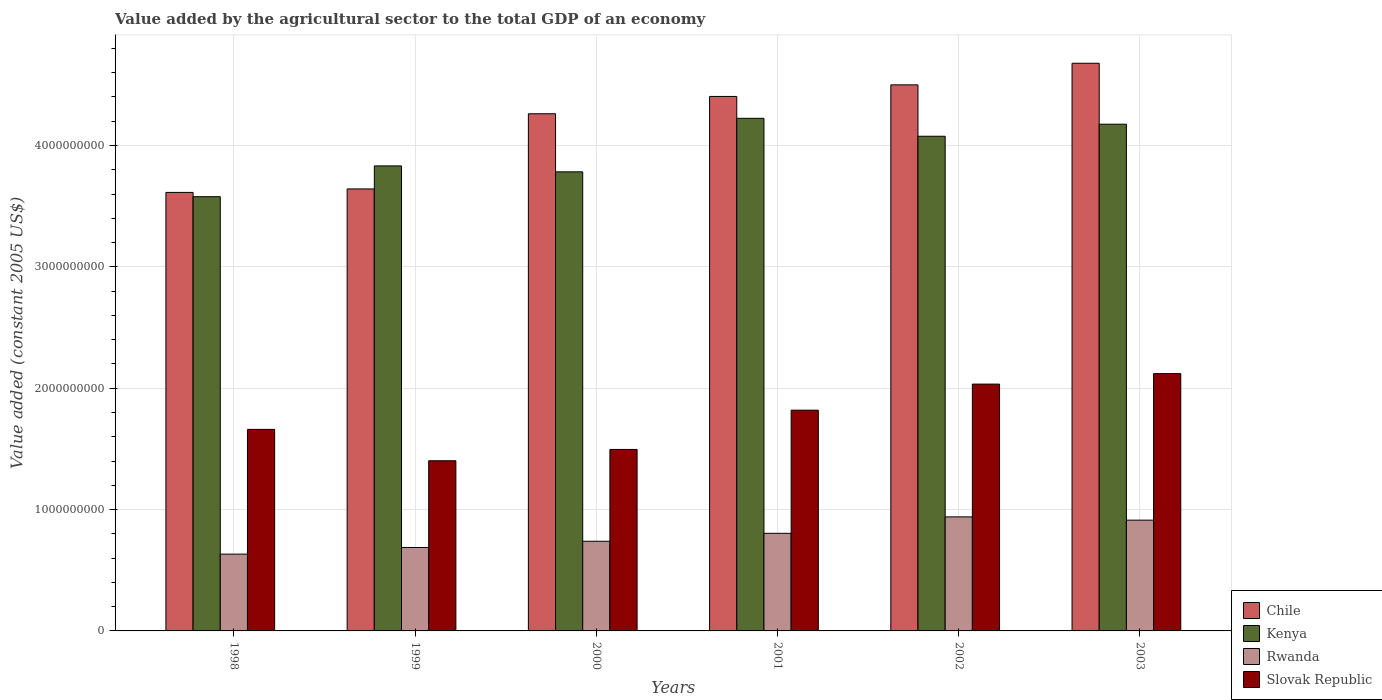How many different coloured bars are there?
Provide a short and direct response. 4. Are the number of bars per tick equal to the number of legend labels?
Give a very brief answer. Yes. How many bars are there on the 4th tick from the left?
Offer a very short reply. 4. How many bars are there on the 6th tick from the right?
Provide a short and direct response. 4. What is the label of the 5th group of bars from the left?
Keep it short and to the point. 2002. What is the value added by the agricultural sector in Kenya in 2003?
Your response must be concise. 4.17e+09. Across all years, what is the maximum value added by the agricultural sector in Kenya?
Offer a terse response. 4.22e+09. Across all years, what is the minimum value added by the agricultural sector in Rwanda?
Provide a short and direct response. 6.33e+08. In which year was the value added by the agricultural sector in Rwanda minimum?
Your answer should be very brief. 1998. What is the total value added by the agricultural sector in Rwanda in the graph?
Offer a terse response. 4.72e+09. What is the difference between the value added by the agricultural sector in Chile in 1999 and that in 2002?
Give a very brief answer. -8.57e+08. What is the difference between the value added by the agricultural sector in Rwanda in 2000 and the value added by the agricultural sector in Slovak Republic in 2001?
Keep it short and to the point. -1.08e+09. What is the average value added by the agricultural sector in Kenya per year?
Your answer should be compact. 3.94e+09. In the year 1999, what is the difference between the value added by the agricultural sector in Kenya and value added by the agricultural sector in Slovak Republic?
Your answer should be very brief. 2.43e+09. What is the ratio of the value added by the agricultural sector in Slovak Republic in 1998 to that in 2000?
Provide a succinct answer. 1.11. Is the difference between the value added by the agricultural sector in Kenya in 1999 and 2001 greater than the difference between the value added by the agricultural sector in Slovak Republic in 1999 and 2001?
Your answer should be compact. Yes. What is the difference between the highest and the second highest value added by the agricultural sector in Rwanda?
Your answer should be compact. 2.68e+07. What is the difference between the highest and the lowest value added by the agricultural sector in Kenya?
Ensure brevity in your answer.  6.46e+08. In how many years, is the value added by the agricultural sector in Slovak Republic greater than the average value added by the agricultural sector in Slovak Republic taken over all years?
Provide a succinct answer. 3. Is it the case that in every year, the sum of the value added by the agricultural sector in Rwanda and value added by the agricultural sector in Kenya is greater than the sum of value added by the agricultural sector in Chile and value added by the agricultural sector in Slovak Republic?
Make the answer very short. Yes. What does the 4th bar from the left in 2002 represents?
Your answer should be compact. Slovak Republic. Is it the case that in every year, the sum of the value added by the agricultural sector in Rwanda and value added by the agricultural sector in Slovak Republic is greater than the value added by the agricultural sector in Kenya?
Make the answer very short. No. How many bars are there?
Keep it short and to the point. 24. Are the values on the major ticks of Y-axis written in scientific E-notation?
Provide a short and direct response. No. Does the graph contain any zero values?
Your answer should be compact. No. How many legend labels are there?
Provide a short and direct response. 4. How are the legend labels stacked?
Ensure brevity in your answer.  Vertical. What is the title of the graph?
Provide a short and direct response. Value added by the agricultural sector to the total GDP of an economy. Does "Gabon" appear as one of the legend labels in the graph?
Make the answer very short. No. What is the label or title of the X-axis?
Make the answer very short. Years. What is the label or title of the Y-axis?
Offer a very short reply. Value added (constant 2005 US$). What is the Value added (constant 2005 US$) in Chile in 1998?
Provide a succinct answer. 3.61e+09. What is the Value added (constant 2005 US$) of Kenya in 1998?
Your answer should be very brief. 3.58e+09. What is the Value added (constant 2005 US$) in Rwanda in 1998?
Make the answer very short. 6.33e+08. What is the Value added (constant 2005 US$) in Slovak Republic in 1998?
Provide a succinct answer. 1.66e+09. What is the Value added (constant 2005 US$) of Chile in 1999?
Offer a very short reply. 3.64e+09. What is the Value added (constant 2005 US$) in Kenya in 1999?
Ensure brevity in your answer.  3.83e+09. What is the Value added (constant 2005 US$) in Rwanda in 1999?
Offer a very short reply. 6.87e+08. What is the Value added (constant 2005 US$) of Slovak Republic in 1999?
Provide a short and direct response. 1.40e+09. What is the Value added (constant 2005 US$) in Chile in 2000?
Give a very brief answer. 4.26e+09. What is the Value added (constant 2005 US$) in Kenya in 2000?
Your answer should be very brief. 3.78e+09. What is the Value added (constant 2005 US$) of Rwanda in 2000?
Make the answer very short. 7.39e+08. What is the Value added (constant 2005 US$) of Slovak Republic in 2000?
Offer a very short reply. 1.50e+09. What is the Value added (constant 2005 US$) of Chile in 2001?
Your response must be concise. 4.40e+09. What is the Value added (constant 2005 US$) of Kenya in 2001?
Ensure brevity in your answer.  4.22e+09. What is the Value added (constant 2005 US$) in Rwanda in 2001?
Offer a very short reply. 8.04e+08. What is the Value added (constant 2005 US$) in Slovak Republic in 2001?
Provide a short and direct response. 1.82e+09. What is the Value added (constant 2005 US$) in Chile in 2002?
Offer a very short reply. 4.50e+09. What is the Value added (constant 2005 US$) in Kenya in 2002?
Keep it short and to the point. 4.08e+09. What is the Value added (constant 2005 US$) of Rwanda in 2002?
Provide a short and direct response. 9.40e+08. What is the Value added (constant 2005 US$) of Slovak Republic in 2002?
Provide a succinct answer. 2.03e+09. What is the Value added (constant 2005 US$) of Chile in 2003?
Your answer should be very brief. 4.68e+09. What is the Value added (constant 2005 US$) of Kenya in 2003?
Provide a succinct answer. 4.17e+09. What is the Value added (constant 2005 US$) of Rwanda in 2003?
Your answer should be very brief. 9.13e+08. What is the Value added (constant 2005 US$) in Slovak Republic in 2003?
Make the answer very short. 2.12e+09. Across all years, what is the maximum Value added (constant 2005 US$) of Chile?
Give a very brief answer. 4.68e+09. Across all years, what is the maximum Value added (constant 2005 US$) of Kenya?
Provide a short and direct response. 4.22e+09. Across all years, what is the maximum Value added (constant 2005 US$) of Rwanda?
Ensure brevity in your answer.  9.40e+08. Across all years, what is the maximum Value added (constant 2005 US$) of Slovak Republic?
Offer a very short reply. 2.12e+09. Across all years, what is the minimum Value added (constant 2005 US$) in Chile?
Offer a very short reply. 3.61e+09. Across all years, what is the minimum Value added (constant 2005 US$) of Kenya?
Your response must be concise. 3.58e+09. Across all years, what is the minimum Value added (constant 2005 US$) in Rwanda?
Your answer should be very brief. 6.33e+08. Across all years, what is the minimum Value added (constant 2005 US$) of Slovak Republic?
Your answer should be very brief. 1.40e+09. What is the total Value added (constant 2005 US$) of Chile in the graph?
Your answer should be compact. 2.51e+1. What is the total Value added (constant 2005 US$) of Kenya in the graph?
Ensure brevity in your answer.  2.37e+1. What is the total Value added (constant 2005 US$) in Rwanda in the graph?
Provide a succinct answer. 4.72e+09. What is the total Value added (constant 2005 US$) in Slovak Republic in the graph?
Give a very brief answer. 1.05e+1. What is the difference between the Value added (constant 2005 US$) of Chile in 1998 and that in 1999?
Provide a succinct answer. -2.87e+07. What is the difference between the Value added (constant 2005 US$) in Kenya in 1998 and that in 1999?
Offer a very short reply. -2.54e+08. What is the difference between the Value added (constant 2005 US$) of Rwanda in 1998 and that in 1999?
Your answer should be very brief. -5.47e+07. What is the difference between the Value added (constant 2005 US$) in Slovak Republic in 1998 and that in 1999?
Your response must be concise. 2.58e+08. What is the difference between the Value added (constant 2005 US$) in Chile in 1998 and that in 2000?
Keep it short and to the point. -6.48e+08. What is the difference between the Value added (constant 2005 US$) of Kenya in 1998 and that in 2000?
Your answer should be compact. -2.05e+08. What is the difference between the Value added (constant 2005 US$) in Rwanda in 1998 and that in 2000?
Make the answer very short. -1.06e+08. What is the difference between the Value added (constant 2005 US$) in Slovak Republic in 1998 and that in 2000?
Keep it short and to the point. 1.65e+08. What is the difference between the Value added (constant 2005 US$) in Chile in 1998 and that in 2001?
Give a very brief answer. -7.91e+08. What is the difference between the Value added (constant 2005 US$) in Kenya in 1998 and that in 2001?
Your response must be concise. -6.46e+08. What is the difference between the Value added (constant 2005 US$) of Rwanda in 1998 and that in 2001?
Ensure brevity in your answer.  -1.71e+08. What is the difference between the Value added (constant 2005 US$) of Slovak Republic in 1998 and that in 2001?
Ensure brevity in your answer.  -1.58e+08. What is the difference between the Value added (constant 2005 US$) of Chile in 1998 and that in 2002?
Ensure brevity in your answer.  -8.86e+08. What is the difference between the Value added (constant 2005 US$) in Kenya in 1998 and that in 2002?
Offer a terse response. -4.98e+08. What is the difference between the Value added (constant 2005 US$) of Rwanda in 1998 and that in 2002?
Provide a short and direct response. -3.07e+08. What is the difference between the Value added (constant 2005 US$) of Slovak Republic in 1998 and that in 2002?
Provide a short and direct response. -3.73e+08. What is the difference between the Value added (constant 2005 US$) in Chile in 1998 and that in 2003?
Your answer should be compact. -1.06e+09. What is the difference between the Value added (constant 2005 US$) in Kenya in 1998 and that in 2003?
Ensure brevity in your answer.  -5.97e+08. What is the difference between the Value added (constant 2005 US$) in Rwanda in 1998 and that in 2003?
Your answer should be very brief. -2.80e+08. What is the difference between the Value added (constant 2005 US$) in Slovak Republic in 1998 and that in 2003?
Offer a very short reply. -4.59e+08. What is the difference between the Value added (constant 2005 US$) of Chile in 1999 and that in 2000?
Provide a short and direct response. -6.19e+08. What is the difference between the Value added (constant 2005 US$) of Kenya in 1999 and that in 2000?
Your answer should be very brief. 4.89e+07. What is the difference between the Value added (constant 2005 US$) of Rwanda in 1999 and that in 2000?
Your answer should be compact. -5.15e+07. What is the difference between the Value added (constant 2005 US$) in Slovak Republic in 1999 and that in 2000?
Make the answer very short. -9.32e+07. What is the difference between the Value added (constant 2005 US$) of Chile in 1999 and that in 2001?
Offer a very short reply. -7.62e+08. What is the difference between the Value added (constant 2005 US$) in Kenya in 1999 and that in 2001?
Keep it short and to the point. -3.92e+08. What is the difference between the Value added (constant 2005 US$) in Rwanda in 1999 and that in 2001?
Provide a succinct answer. -1.17e+08. What is the difference between the Value added (constant 2005 US$) of Slovak Republic in 1999 and that in 2001?
Offer a terse response. -4.17e+08. What is the difference between the Value added (constant 2005 US$) of Chile in 1999 and that in 2002?
Provide a succinct answer. -8.57e+08. What is the difference between the Value added (constant 2005 US$) of Kenya in 1999 and that in 2002?
Offer a terse response. -2.44e+08. What is the difference between the Value added (constant 2005 US$) in Rwanda in 1999 and that in 2002?
Offer a terse response. -2.52e+08. What is the difference between the Value added (constant 2005 US$) in Slovak Republic in 1999 and that in 2002?
Keep it short and to the point. -6.32e+08. What is the difference between the Value added (constant 2005 US$) in Chile in 1999 and that in 2003?
Your response must be concise. -1.04e+09. What is the difference between the Value added (constant 2005 US$) of Kenya in 1999 and that in 2003?
Keep it short and to the point. -3.43e+08. What is the difference between the Value added (constant 2005 US$) of Rwanda in 1999 and that in 2003?
Your answer should be compact. -2.25e+08. What is the difference between the Value added (constant 2005 US$) of Slovak Republic in 1999 and that in 2003?
Keep it short and to the point. -7.18e+08. What is the difference between the Value added (constant 2005 US$) in Chile in 2000 and that in 2001?
Provide a short and direct response. -1.43e+08. What is the difference between the Value added (constant 2005 US$) of Kenya in 2000 and that in 2001?
Offer a terse response. -4.41e+08. What is the difference between the Value added (constant 2005 US$) of Rwanda in 2000 and that in 2001?
Offer a terse response. -6.52e+07. What is the difference between the Value added (constant 2005 US$) of Slovak Republic in 2000 and that in 2001?
Offer a very short reply. -3.24e+08. What is the difference between the Value added (constant 2005 US$) in Chile in 2000 and that in 2002?
Your answer should be very brief. -2.38e+08. What is the difference between the Value added (constant 2005 US$) of Kenya in 2000 and that in 2002?
Your answer should be very brief. -2.93e+08. What is the difference between the Value added (constant 2005 US$) of Rwanda in 2000 and that in 2002?
Your answer should be compact. -2.01e+08. What is the difference between the Value added (constant 2005 US$) of Slovak Republic in 2000 and that in 2002?
Keep it short and to the point. -5.38e+08. What is the difference between the Value added (constant 2005 US$) of Chile in 2000 and that in 2003?
Keep it short and to the point. -4.16e+08. What is the difference between the Value added (constant 2005 US$) of Kenya in 2000 and that in 2003?
Your answer should be very brief. -3.92e+08. What is the difference between the Value added (constant 2005 US$) in Rwanda in 2000 and that in 2003?
Your response must be concise. -1.74e+08. What is the difference between the Value added (constant 2005 US$) in Slovak Republic in 2000 and that in 2003?
Your answer should be compact. -6.25e+08. What is the difference between the Value added (constant 2005 US$) in Chile in 2001 and that in 2002?
Your answer should be very brief. -9.54e+07. What is the difference between the Value added (constant 2005 US$) in Kenya in 2001 and that in 2002?
Your answer should be compact. 1.48e+08. What is the difference between the Value added (constant 2005 US$) of Rwanda in 2001 and that in 2002?
Your answer should be very brief. -1.35e+08. What is the difference between the Value added (constant 2005 US$) in Slovak Republic in 2001 and that in 2002?
Offer a very short reply. -2.15e+08. What is the difference between the Value added (constant 2005 US$) of Chile in 2001 and that in 2003?
Your answer should be compact. -2.73e+08. What is the difference between the Value added (constant 2005 US$) of Kenya in 2001 and that in 2003?
Give a very brief answer. 4.86e+07. What is the difference between the Value added (constant 2005 US$) in Rwanda in 2001 and that in 2003?
Make the answer very short. -1.09e+08. What is the difference between the Value added (constant 2005 US$) in Slovak Republic in 2001 and that in 2003?
Your response must be concise. -3.01e+08. What is the difference between the Value added (constant 2005 US$) in Chile in 2002 and that in 2003?
Your answer should be very brief. -1.78e+08. What is the difference between the Value added (constant 2005 US$) in Kenya in 2002 and that in 2003?
Ensure brevity in your answer.  -9.91e+07. What is the difference between the Value added (constant 2005 US$) of Rwanda in 2002 and that in 2003?
Offer a very short reply. 2.68e+07. What is the difference between the Value added (constant 2005 US$) of Slovak Republic in 2002 and that in 2003?
Keep it short and to the point. -8.63e+07. What is the difference between the Value added (constant 2005 US$) of Chile in 1998 and the Value added (constant 2005 US$) of Kenya in 1999?
Provide a succinct answer. -2.18e+08. What is the difference between the Value added (constant 2005 US$) of Chile in 1998 and the Value added (constant 2005 US$) of Rwanda in 1999?
Make the answer very short. 2.93e+09. What is the difference between the Value added (constant 2005 US$) in Chile in 1998 and the Value added (constant 2005 US$) in Slovak Republic in 1999?
Offer a terse response. 2.21e+09. What is the difference between the Value added (constant 2005 US$) of Kenya in 1998 and the Value added (constant 2005 US$) of Rwanda in 1999?
Provide a short and direct response. 2.89e+09. What is the difference between the Value added (constant 2005 US$) in Kenya in 1998 and the Value added (constant 2005 US$) in Slovak Republic in 1999?
Ensure brevity in your answer.  2.18e+09. What is the difference between the Value added (constant 2005 US$) in Rwanda in 1998 and the Value added (constant 2005 US$) in Slovak Republic in 1999?
Offer a very short reply. -7.69e+08. What is the difference between the Value added (constant 2005 US$) in Chile in 1998 and the Value added (constant 2005 US$) in Kenya in 2000?
Offer a very short reply. -1.70e+08. What is the difference between the Value added (constant 2005 US$) in Chile in 1998 and the Value added (constant 2005 US$) in Rwanda in 2000?
Ensure brevity in your answer.  2.87e+09. What is the difference between the Value added (constant 2005 US$) of Chile in 1998 and the Value added (constant 2005 US$) of Slovak Republic in 2000?
Offer a terse response. 2.12e+09. What is the difference between the Value added (constant 2005 US$) in Kenya in 1998 and the Value added (constant 2005 US$) in Rwanda in 2000?
Your response must be concise. 2.84e+09. What is the difference between the Value added (constant 2005 US$) of Kenya in 1998 and the Value added (constant 2005 US$) of Slovak Republic in 2000?
Keep it short and to the point. 2.08e+09. What is the difference between the Value added (constant 2005 US$) of Rwanda in 1998 and the Value added (constant 2005 US$) of Slovak Republic in 2000?
Your answer should be compact. -8.63e+08. What is the difference between the Value added (constant 2005 US$) in Chile in 1998 and the Value added (constant 2005 US$) in Kenya in 2001?
Your answer should be very brief. -6.10e+08. What is the difference between the Value added (constant 2005 US$) of Chile in 1998 and the Value added (constant 2005 US$) of Rwanda in 2001?
Your response must be concise. 2.81e+09. What is the difference between the Value added (constant 2005 US$) of Chile in 1998 and the Value added (constant 2005 US$) of Slovak Republic in 2001?
Offer a terse response. 1.79e+09. What is the difference between the Value added (constant 2005 US$) in Kenya in 1998 and the Value added (constant 2005 US$) in Rwanda in 2001?
Give a very brief answer. 2.77e+09. What is the difference between the Value added (constant 2005 US$) in Kenya in 1998 and the Value added (constant 2005 US$) in Slovak Republic in 2001?
Offer a very short reply. 1.76e+09. What is the difference between the Value added (constant 2005 US$) in Rwanda in 1998 and the Value added (constant 2005 US$) in Slovak Republic in 2001?
Your response must be concise. -1.19e+09. What is the difference between the Value added (constant 2005 US$) in Chile in 1998 and the Value added (constant 2005 US$) in Kenya in 2002?
Your response must be concise. -4.63e+08. What is the difference between the Value added (constant 2005 US$) in Chile in 1998 and the Value added (constant 2005 US$) in Rwanda in 2002?
Your answer should be compact. 2.67e+09. What is the difference between the Value added (constant 2005 US$) in Chile in 1998 and the Value added (constant 2005 US$) in Slovak Republic in 2002?
Your answer should be compact. 1.58e+09. What is the difference between the Value added (constant 2005 US$) in Kenya in 1998 and the Value added (constant 2005 US$) in Rwanda in 2002?
Your answer should be very brief. 2.64e+09. What is the difference between the Value added (constant 2005 US$) of Kenya in 1998 and the Value added (constant 2005 US$) of Slovak Republic in 2002?
Make the answer very short. 1.54e+09. What is the difference between the Value added (constant 2005 US$) of Rwanda in 1998 and the Value added (constant 2005 US$) of Slovak Republic in 2002?
Keep it short and to the point. -1.40e+09. What is the difference between the Value added (constant 2005 US$) of Chile in 1998 and the Value added (constant 2005 US$) of Kenya in 2003?
Provide a succinct answer. -5.62e+08. What is the difference between the Value added (constant 2005 US$) in Chile in 1998 and the Value added (constant 2005 US$) in Rwanda in 2003?
Keep it short and to the point. 2.70e+09. What is the difference between the Value added (constant 2005 US$) in Chile in 1998 and the Value added (constant 2005 US$) in Slovak Republic in 2003?
Your answer should be compact. 1.49e+09. What is the difference between the Value added (constant 2005 US$) in Kenya in 1998 and the Value added (constant 2005 US$) in Rwanda in 2003?
Offer a very short reply. 2.67e+09. What is the difference between the Value added (constant 2005 US$) in Kenya in 1998 and the Value added (constant 2005 US$) in Slovak Republic in 2003?
Offer a very short reply. 1.46e+09. What is the difference between the Value added (constant 2005 US$) of Rwanda in 1998 and the Value added (constant 2005 US$) of Slovak Republic in 2003?
Offer a terse response. -1.49e+09. What is the difference between the Value added (constant 2005 US$) in Chile in 1999 and the Value added (constant 2005 US$) in Kenya in 2000?
Give a very brief answer. -1.41e+08. What is the difference between the Value added (constant 2005 US$) of Chile in 1999 and the Value added (constant 2005 US$) of Rwanda in 2000?
Your response must be concise. 2.90e+09. What is the difference between the Value added (constant 2005 US$) of Chile in 1999 and the Value added (constant 2005 US$) of Slovak Republic in 2000?
Offer a very short reply. 2.15e+09. What is the difference between the Value added (constant 2005 US$) in Kenya in 1999 and the Value added (constant 2005 US$) in Rwanda in 2000?
Your response must be concise. 3.09e+09. What is the difference between the Value added (constant 2005 US$) of Kenya in 1999 and the Value added (constant 2005 US$) of Slovak Republic in 2000?
Offer a terse response. 2.34e+09. What is the difference between the Value added (constant 2005 US$) in Rwanda in 1999 and the Value added (constant 2005 US$) in Slovak Republic in 2000?
Provide a succinct answer. -8.08e+08. What is the difference between the Value added (constant 2005 US$) of Chile in 1999 and the Value added (constant 2005 US$) of Kenya in 2001?
Your answer should be very brief. -5.82e+08. What is the difference between the Value added (constant 2005 US$) in Chile in 1999 and the Value added (constant 2005 US$) in Rwanda in 2001?
Ensure brevity in your answer.  2.84e+09. What is the difference between the Value added (constant 2005 US$) of Chile in 1999 and the Value added (constant 2005 US$) of Slovak Republic in 2001?
Give a very brief answer. 1.82e+09. What is the difference between the Value added (constant 2005 US$) of Kenya in 1999 and the Value added (constant 2005 US$) of Rwanda in 2001?
Offer a very short reply. 3.03e+09. What is the difference between the Value added (constant 2005 US$) in Kenya in 1999 and the Value added (constant 2005 US$) in Slovak Republic in 2001?
Provide a short and direct response. 2.01e+09. What is the difference between the Value added (constant 2005 US$) in Rwanda in 1999 and the Value added (constant 2005 US$) in Slovak Republic in 2001?
Your response must be concise. -1.13e+09. What is the difference between the Value added (constant 2005 US$) of Chile in 1999 and the Value added (constant 2005 US$) of Kenya in 2002?
Keep it short and to the point. -4.34e+08. What is the difference between the Value added (constant 2005 US$) in Chile in 1999 and the Value added (constant 2005 US$) in Rwanda in 2002?
Your answer should be compact. 2.70e+09. What is the difference between the Value added (constant 2005 US$) in Chile in 1999 and the Value added (constant 2005 US$) in Slovak Republic in 2002?
Keep it short and to the point. 1.61e+09. What is the difference between the Value added (constant 2005 US$) of Kenya in 1999 and the Value added (constant 2005 US$) of Rwanda in 2002?
Ensure brevity in your answer.  2.89e+09. What is the difference between the Value added (constant 2005 US$) of Kenya in 1999 and the Value added (constant 2005 US$) of Slovak Republic in 2002?
Your answer should be compact. 1.80e+09. What is the difference between the Value added (constant 2005 US$) of Rwanda in 1999 and the Value added (constant 2005 US$) of Slovak Republic in 2002?
Your answer should be compact. -1.35e+09. What is the difference between the Value added (constant 2005 US$) of Chile in 1999 and the Value added (constant 2005 US$) of Kenya in 2003?
Give a very brief answer. -5.33e+08. What is the difference between the Value added (constant 2005 US$) in Chile in 1999 and the Value added (constant 2005 US$) in Rwanda in 2003?
Provide a short and direct response. 2.73e+09. What is the difference between the Value added (constant 2005 US$) of Chile in 1999 and the Value added (constant 2005 US$) of Slovak Republic in 2003?
Offer a very short reply. 1.52e+09. What is the difference between the Value added (constant 2005 US$) in Kenya in 1999 and the Value added (constant 2005 US$) in Rwanda in 2003?
Give a very brief answer. 2.92e+09. What is the difference between the Value added (constant 2005 US$) of Kenya in 1999 and the Value added (constant 2005 US$) of Slovak Republic in 2003?
Provide a short and direct response. 1.71e+09. What is the difference between the Value added (constant 2005 US$) of Rwanda in 1999 and the Value added (constant 2005 US$) of Slovak Republic in 2003?
Give a very brief answer. -1.43e+09. What is the difference between the Value added (constant 2005 US$) in Chile in 2000 and the Value added (constant 2005 US$) in Kenya in 2001?
Ensure brevity in your answer.  3.75e+07. What is the difference between the Value added (constant 2005 US$) of Chile in 2000 and the Value added (constant 2005 US$) of Rwanda in 2001?
Offer a very short reply. 3.46e+09. What is the difference between the Value added (constant 2005 US$) in Chile in 2000 and the Value added (constant 2005 US$) in Slovak Republic in 2001?
Your response must be concise. 2.44e+09. What is the difference between the Value added (constant 2005 US$) in Kenya in 2000 and the Value added (constant 2005 US$) in Rwanda in 2001?
Provide a short and direct response. 2.98e+09. What is the difference between the Value added (constant 2005 US$) of Kenya in 2000 and the Value added (constant 2005 US$) of Slovak Republic in 2001?
Offer a very short reply. 1.96e+09. What is the difference between the Value added (constant 2005 US$) in Rwanda in 2000 and the Value added (constant 2005 US$) in Slovak Republic in 2001?
Your answer should be compact. -1.08e+09. What is the difference between the Value added (constant 2005 US$) in Chile in 2000 and the Value added (constant 2005 US$) in Kenya in 2002?
Make the answer very short. 1.85e+08. What is the difference between the Value added (constant 2005 US$) of Chile in 2000 and the Value added (constant 2005 US$) of Rwanda in 2002?
Offer a terse response. 3.32e+09. What is the difference between the Value added (constant 2005 US$) of Chile in 2000 and the Value added (constant 2005 US$) of Slovak Republic in 2002?
Make the answer very short. 2.23e+09. What is the difference between the Value added (constant 2005 US$) in Kenya in 2000 and the Value added (constant 2005 US$) in Rwanda in 2002?
Your answer should be compact. 2.84e+09. What is the difference between the Value added (constant 2005 US$) of Kenya in 2000 and the Value added (constant 2005 US$) of Slovak Republic in 2002?
Your response must be concise. 1.75e+09. What is the difference between the Value added (constant 2005 US$) of Rwanda in 2000 and the Value added (constant 2005 US$) of Slovak Republic in 2002?
Provide a succinct answer. -1.29e+09. What is the difference between the Value added (constant 2005 US$) of Chile in 2000 and the Value added (constant 2005 US$) of Kenya in 2003?
Your answer should be compact. 8.61e+07. What is the difference between the Value added (constant 2005 US$) in Chile in 2000 and the Value added (constant 2005 US$) in Rwanda in 2003?
Keep it short and to the point. 3.35e+09. What is the difference between the Value added (constant 2005 US$) in Chile in 2000 and the Value added (constant 2005 US$) in Slovak Republic in 2003?
Offer a terse response. 2.14e+09. What is the difference between the Value added (constant 2005 US$) in Kenya in 2000 and the Value added (constant 2005 US$) in Rwanda in 2003?
Give a very brief answer. 2.87e+09. What is the difference between the Value added (constant 2005 US$) of Kenya in 2000 and the Value added (constant 2005 US$) of Slovak Republic in 2003?
Offer a terse response. 1.66e+09. What is the difference between the Value added (constant 2005 US$) of Rwanda in 2000 and the Value added (constant 2005 US$) of Slovak Republic in 2003?
Ensure brevity in your answer.  -1.38e+09. What is the difference between the Value added (constant 2005 US$) of Chile in 2001 and the Value added (constant 2005 US$) of Kenya in 2002?
Your response must be concise. 3.28e+08. What is the difference between the Value added (constant 2005 US$) in Chile in 2001 and the Value added (constant 2005 US$) in Rwanda in 2002?
Your response must be concise. 3.46e+09. What is the difference between the Value added (constant 2005 US$) of Chile in 2001 and the Value added (constant 2005 US$) of Slovak Republic in 2002?
Your answer should be compact. 2.37e+09. What is the difference between the Value added (constant 2005 US$) of Kenya in 2001 and the Value added (constant 2005 US$) of Rwanda in 2002?
Provide a succinct answer. 3.28e+09. What is the difference between the Value added (constant 2005 US$) of Kenya in 2001 and the Value added (constant 2005 US$) of Slovak Republic in 2002?
Keep it short and to the point. 2.19e+09. What is the difference between the Value added (constant 2005 US$) of Rwanda in 2001 and the Value added (constant 2005 US$) of Slovak Republic in 2002?
Offer a very short reply. -1.23e+09. What is the difference between the Value added (constant 2005 US$) of Chile in 2001 and the Value added (constant 2005 US$) of Kenya in 2003?
Give a very brief answer. 2.29e+08. What is the difference between the Value added (constant 2005 US$) in Chile in 2001 and the Value added (constant 2005 US$) in Rwanda in 2003?
Give a very brief answer. 3.49e+09. What is the difference between the Value added (constant 2005 US$) of Chile in 2001 and the Value added (constant 2005 US$) of Slovak Republic in 2003?
Provide a short and direct response. 2.28e+09. What is the difference between the Value added (constant 2005 US$) in Kenya in 2001 and the Value added (constant 2005 US$) in Rwanda in 2003?
Offer a very short reply. 3.31e+09. What is the difference between the Value added (constant 2005 US$) of Kenya in 2001 and the Value added (constant 2005 US$) of Slovak Republic in 2003?
Offer a very short reply. 2.10e+09. What is the difference between the Value added (constant 2005 US$) of Rwanda in 2001 and the Value added (constant 2005 US$) of Slovak Republic in 2003?
Offer a very short reply. -1.32e+09. What is the difference between the Value added (constant 2005 US$) of Chile in 2002 and the Value added (constant 2005 US$) of Kenya in 2003?
Offer a terse response. 3.24e+08. What is the difference between the Value added (constant 2005 US$) in Chile in 2002 and the Value added (constant 2005 US$) in Rwanda in 2003?
Offer a terse response. 3.59e+09. What is the difference between the Value added (constant 2005 US$) in Chile in 2002 and the Value added (constant 2005 US$) in Slovak Republic in 2003?
Your answer should be very brief. 2.38e+09. What is the difference between the Value added (constant 2005 US$) in Kenya in 2002 and the Value added (constant 2005 US$) in Rwanda in 2003?
Make the answer very short. 3.16e+09. What is the difference between the Value added (constant 2005 US$) of Kenya in 2002 and the Value added (constant 2005 US$) of Slovak Republic in 2003?
Ensure brevity in your answer.  1.96e+09. What is the difference between the Value added (constant 2005 US$) of Rwanda in 2002 and the Value added (constant 2005 US$) of Slovak Republic in 2003?
Your answer should be very brief. -1.18e+09. What is the average Value added (constant 2005 US$) of Chile per year?
Provide a short and direct response. 4.18e+09. What is the average Value added (constant 2005 US$) of Kenya per year?
Your answer should be compact. 3.94e+09. What is the average Value added (constant 2005 US$) in Rwanda per year?
Offer a very short reply. 7.86e+08. What is the average Value added (constant 2005 US$) in Slovak Republic per year?
Offer a very short reply. 1.76e+09. In the year 1998, what is the difference between the Value added (constant 2005 US$) of Chile and Value added (constant 2005 US$) of Kenya?
Offer a very short reply. 3.53e+07. In the year 1998, what is the difference between the Value added (constant 2005 US$) of Chile and Value added (constant 2005 US$) of Rwanda?
Ensure brevity in your answer.  2.98e+09. In the year 1998, what is the difference between the Value added (constant 2005 US$) in Chile and Value added (constant 2005 US$) in Slovak Republic?
Provide a short and direct response. 1.95e+09. In the year 1998, what is the difference between the Value added (constant 2005 US$) of Kenya and Value added (constant 2005 US$) of Rwanda?
Keep it short and to the point. 2.95e+09. In the year 1998, what is the difference between the Value added (constant 2005 US$) of Kenya and Value added (constant 2005 US$) of Slovak Republic?
Your response must be concise. 1.92e+09. In the year 1998, what is the difference between the Value added (constant 2005 US$) in Rwanda and Value added (constant 2005 US$) in Slovak Republic?
Make the answer very short. -1.03e+09. In the year 1999, what is the difference between the Value added (constant 2005 US$) in Chile and Value added (constant 2005 US$) in Kenya?
Ensure brevity in your answer.  -1.90e+08. In the year 1999, what is the difference between the Value added (constant 2005 US$) in Chile and Value added (constant 2005 US$) in Rwanda?
Offer a terse response. 2.95e+09. In the year 1999, what is the difference between the Value added (constant 2005 US$) of Chile and Value added (constant 2005 US$) of Slovak Republic?
Your response must be concise. 2.24e+09. In the year 1999, what is the difference between the Value added (constant 2005 US$) in Kenya and Value added (constant 2005 US$) in Rwanda?
Your response must be concise. 3.14e+09. In the year 1999, what is the difference between the Value added (constant 2005 US$) of Kenya and Value added (constant 2005 US$) of Slovak Republic?
Make the answer very short. 2.43e+09. In the year 1999, what is the difference between the Value added (constant 2005 US$) of Rwanda and Value added (constant 2005 US$) of Slovak Republic?
Provide a short and direct response. -7.15e+08. In the year 2000, what is the difference between the Value added (constant 2005 US$) of Chile and Value added (constant 2005 US$) of Kenya?
Provide a succinct answer. 4.79e+08. In the year 2000, what is the difference between the Value added (constant 2005 US$) in Chile and Value added (constant 2005 US$) in Rwanda?
Make the answer very short. 3.52e+09. In the year 2000, what is the difference between the Value added (constant 2005 US$) in Chile and Value added (constant 2005 US$) in Slovak Republic?
Your response must be concise. 2.77e+09. In the year 2000, what is the difference between the Value added (constant 2005 US$) of Kenya and Value added (constant 2005 US$) of Rwanda?
Offer a terse response. 3.04e+09. In the year 2000, what is the difference between the Value added (constant 2005 US$) in Kenya and Value added (constant 2005 US$) in Slovak Republic?
Keep it short and to the point. 2.29e+09. In the year 2000, what is the difference between the Value added (constant 2005 US$) in Rwanda and Value added (constant 2005 US$) in Slovak Republic?
Your answer should be compact. -7.56e+08. In the year 2001, what is the difference between the Value added (constant 2005 US$) in Chile and Value added (constant 2005 US$) in Kenya?
Keep it short and to the point. 1.80e+08. In the year 2001, what is the difference between the Value added (constant 2005 US$) in Chile and Value added (constant 2005 US$) in Rwanda?
Keep it short and to the point. 3.60e+09. In the year 2001, what is the difference between the Value added (constant 2005 US$) of Chile and Value added (constant 2005 US$) of Slovak Republic?
Offer a very short reply. 2.58e+09. In the year 2001, what is the difference between the Value added (constant 2005 US$) of Kenya and Value added (constant 2005 US$) of Rwanda?
Ensure brevity in your answer.  3.42e+09. In the year 2001, what is the difference between the Value added (constant 2005 US$) in Kenya and Value added (constant 2005 US$) in Slovak Republic?
Provide a succinct answer. 2.40e+09. In the year 2001, what is the difference between the Value added (constant 2005 US$) of Rwanda and Value added (constant 2005 US$) of Slovak Republic?
Offer a very short reply. -1.01e+09. In the year 2002, what is the difference between the Value added (constant 2005 US$) of Chile and Value added (constant 2005 US$) of Kenya?
Your answer should be compact. 4.23e+08. In the year 2002, what is the difference between the Value added (constant 2005 US$) in Chile and Value added (constant 2005 US$) in Rwanda?
Ensure brevity in your answer.  3.56e+09. In the year 2002, what is the difference between the Value added (constant 2005 US$) of Chile and Value added (constant 2005 US$) of Slovak Republic?
Keep it short and to the point. 2.47e+09. In the year 2002, what is the difference between the Value added (constant 2005 US$) of Kenya and Value added (constant 2005 US$) of Rwanda?
Make the answer very short. 3.14e+09. In the year 2002, what is the difference between the Value added (constant 2005 US$) of Kenya and Value added (constant 2005 US$) of Slovak Republic?
Provide a short and direct response. 2.04e+09. In the year 2002, what is the difference between the Value added (constant 2005 US$) in Rwanda and Value added (constant 2005 US$) in Slovak Republic?
Provide a short and direct response. -1.09e+09. In the year 2003, what is the difference between the Value added (constant 2005 US$) of Chile and Value added (constant 2005 US$) of Kenya?
Provide a succinct answer. 5.02e+08. In the year 2003, what is the difference between the Value added (constant 2005 US$) of Chile and Value added (constant 2005 US$) of Rwanda?
Provide a succinct answer. 3.76e+09. In the year 2003, what is the difference between the Value added (constant 2005 US$) of Chile and Value added (constant 2005 US$) of Slovak Republic?
Provide a succinct answer. 2.56e+09. In the year 2003, what is the difference between the Value added (constant 2005 US$) of Kenya and Value added (constant 2005 US$) of Rwanda?
Your response must be concise. 3.26e+09. In the year 2003, what is the difference between the Value added (constant 2005 US$) of Kenya and Value added (constant 2005 US$) of Slovak Republic?
Give a very brief answer. 2.06e+09. In the year 2003, what is the difference between the Value added (constant 2005 US$) of Rwanda and Value added (constant 2005 US$) of Slovak Republic?
Provide a short and direct response. -1.21e+09. What is the ratio of the Value added (constant 2005 US$) of Kenya in 1998 to that in 1999?
Your response must be concise. 0.93. What is the ratio of the Value added (constant 2005 US$) in Rwanda in 1998 to that in 1999?
Give a very brief answer. 0.92. What is the ratio of the Value added (constant 2005 US$) of Slovak Republic in 1998 to that in 1999?
Your response must be concise. 1.18. What is the ratio of the Value added (constant 2005 US$) in Chile in 1998 to that in 2000?
Ensure brevity in your answer.  0.85. What is the ratio of the Value added (constant 2005 US$) in Kenya in 1998 to that in 2000?
Offer a very short reply. 0.95. What is the ratio of the Value added (constant 2005 US$) in Rwanda in 1998 to that in 2000?
Offer a terse response. 0.86. What is the ratio of the Value added (constant 2005 US$) in Slovak Republic in 1998 to that in 2000?
Provide a succinct answer. 1.11. What is the ratio of the Value added (constant 2005 US$) of Chile in 1998 to that in 2001?
Your answer should be very brief. 0.82. What is the ratio of the Value added (constant 2005 US$) in Kenya in 1998 to that in 2001?
Provide a succinct answer. 0.85. What is the ratio of the Value added (constant 2005 US$) of Rwanda in 1998 to that in 2001?
Your answer should be compact. 0.79. What is the ratio of the Value added (constant 2005 US$) of Slovak Republic in 1998 to that in 2001?
Make the answer very short. 0.91. What is the ratio of the Value added (constant 2005 US$) of Chile in 1998 to that in 2002?
Provide a short and direct response. 0.8. What is the ratio of the Value added (constant 2005 US$) of Kenya in 1998 to that in 2002?
Your response must be concise. 0.88. What is the ratio of the Value added (constant 2005 US$) in Rwanda in 1998 to that in 2002?
Your answer should be compact. 0.67. What is the ratio of the Value added (constant 2005 US$) of Slovak Republic in 1998 to that in 2002?
Keep it short and to the point. 0.82. What is the ratio of the Value added (constant 2005 US$) in Chile in 1998 to that in 2003?
Offer a terse response. 0.77. What is the ratio of the Value added (constant 2005 US$) in Kenya in 1998 to that in 2003?
Offer a very short reply. 0.86. What is the ratio of the Value added (constant 2005 US$) of Rwanda in 1998 to that in 2003?
Offer a terse response. 0.69. What is the ratio of the Value added (constant 2005 US$) in Slovak Republic in 1998 to that in 2003?
Ensure brevity in your answer.  0.78. What is the ratio of the Value added (constant 2005 US$) in Chile in 1999 to that in 2000?
Provide a succinct answer. 0.85. What is the ratio of the Value added (constant 2005 US$) in Kenya in 1999 to that in 2000?
Ensure brevity in your answer.  1.01. What is the ratio of the Value added (constant 2005 US$) in Rwanda in 1999 to that in 2000?
Ensure brevity in your answer.  0.93. What is the ratio of the Value added (constant 2005 US$) in Slovak Republic in 1999 to that in 2000?
Ensure brevity in your answer.  0.94. What is the ratio of the Value added (constant 2005 US$) of Chile in 1999 to that in 2001?
Keep it short and to the point. 0.83. What is the ratio of the Value added (constant 2005 US$) in Kenya in 1999 to that in 2001?
Your response must be concise. 0.91. What is the ratio of the Value added (constant 2005 US$) in Rwanda in 1999 to that in 2001?
Offer a terse response. 0.85. What is the ratio of the Value added (constant 2005 US$) in Slovak Republic in 1999 to that in 2001?
Give a very brief answer. 0.77. What is the ratio of the Value added (constant 2005 US$) of Chile in 1999 to that in 2002?
Your answer should be compact. 0.81. What is the ratio of the Value added (constant 2005 US$) in Rwanda in 1999 to that in 2002?
Provide a succinct answer. 0.73. What is the ratio of the Value added (constant 2005 US$) in Slovak Republic in 1999 to that in 2002?
Keep it short and to the point. 0.69. What is the ratio of the Value added (constant 2005 US$) of Chile in 1999 to that in 2003?
Your response must be concise. 0.78. What is the ratio of the Value added (constant 2005 US$) in Kenya in 1999 to that in 2003?
Offer a very short reply. 0.92. What is the ratio of the Value added (constant 2005 US$) of Rwanda in 1999 to that in 2003?
Ensure brevity in your answer.  0.75. What is the ratio of the Value added (constant 2005 US$) in Slovak Republic in 1999 to that in 2003?
Keep it short and to the point. 0.66. What is the ratio of the Value added (constant 2005 US$) in Chile in 2000 to that in 2001?
Keep it short and to the point. 0.97. What is the ratio of the Value added (constant 2005 US$) in Kenya in 2000 to that in 2001?
Keep it short and to the point. 0.9. What is the ratio of the Value added (constant 2005 US$) of Rwanda in 2000 to that in 2001?
Your answer should be very brief. 0.92. What is the ratio of the Value added (constant 2005 US$) of Slovak Republic in 2000 to that in 2001?
Make the answer very short. 0.82. What is the ratio of the Value added (constant 2005 US$) in Chile in 2000 to that in 2002?
Ensure brevity in your answer.  0.95. What is the ratio of the Value added (constant 2005 US$) of Kenya in 2000 to that in 2002?
Provide a short and direct response. 0.93. What is the ratio of the Value added (constant 2005 US$) of Rwanda in 2000 to that in 2002?
Your response must be concise. 0.79. What is the ratio of the Value added (constant 2005 US$) in Slovak Republic in 2000 to that in 2002?
Make the answer very short. 0.74. What is the ratio of the Value added (constant 2005 US$) of Chile in 2000 to that in 2003?
Give a very brief answer. 0.91. What is the ratio of the Value added (constant 2005 US$) of Kenya in 2000 to that in 2003?
Offer a terse response. 0.91. What is the ratio of the Value added (constant 2005 US$) in Rwanda in 2000 to that in 2003?
Make the answer very short. 0.81. What is the ratio of the Value added (constant 2005 US$) of Slovak Republic in 2000 to that in 2003?
Offer a terse response. 0.71. What is the ratio of the Value added (constant 2005 US$) in Chile in 2001 to that in 2002?
Provide a succinct answer. 0.98. What is the ratio of the Value added (constant 2005 US$) in Kenya in 2001 to that in 2002?
Provide a succinct answer. 1.04. What is the ratio of the Value added (constant 2005 US$) of Rwanda in 2001 to that in 2002?
Ensure brevity in your answer.  0.86. What is the ratio of the Value added (constant 2005 US$) of Slovak Republic in 2001 to that in 2002?
Your answer should be very brief. 0.89. What is the ratio of the Value added (constant 2005 US$) of Chile in 2001 to that in 2003?
Ensure brevity in your answer.  0.94. What is the ratio of the Value added (constant 2005 US$) in Kenya in 2001 to that in 2003?
Provide a short and direct response. 1.01. What is the ratio of the Value added (constant 2005 US$) of Rwanda in 2001 to that in 2003?
Provide a short and direct response. 0.88. What is the ratio of the Value added (constant 2005 US$) of Slovak Republic in 2001 to that in 2003?
Provide a short and direct response. 0.86. What is the ratio of the Value added (constant 2005 US$) of Chile in 2002 to that in 2003?
Provide a short and direct response. 0.96. What is the ratio of the Value added (constant 2005 US$) in Kenya in 2002 to that in 2003?
Offer a terse response. 0.98. What is the ratio of the Value added (constant 2005 US$) of Rwanda in 2002 to that in 2003?
Ensure brevity in your answer.  1.03. What is the ratio of the Value added (constant 2005 US$) in Slovak Republic in 2002 to that in 2003?
Give a very brief answer. 0.96. What is the difference between the highest and the second highest Value added (constant 2005 US$) in Chile?
Give a very brief answer. 1.78e+08. What is the difference between the highest and the second highest Value added (constant 2005 US$) in Kenya?
Give a very brief answer. 4.86e+07. What is the difference between the highest and the second highest Value added (constant 2005 US$) in Rwanda?
Provide a succinct answer. 2.68e+07. What is the difference between the highest and the second highest Value added (constant 2005 US$) in Slovak Republic?
Your answer should be compact. 8.63e+07. What is the difference between the highest and the lowest Value added (constant 2005 US$) in Chile?
Your answer should be compact. 1.06e+09. What is the difference between the highest and the lowest Value added (constant 2005 US$) of Kenya?
Make the answer very short. 6.46e+08. What is the difference between the highest and the lowest Value added (constant 2005 US$) in Rwanda?
Keep it short and to the point. 3.07e+08. What is the difference between the highest and the lowest Value added (constant 2005 US$) of Slovak Republic?
Your answer should be very brief. 7.18e+08. 